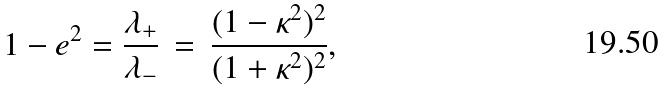Convert formula to latex. <formula><loc_0><loc_0><loc_500><loc_500>1 - e ^ { 2 } = \frac { { \lambda } _ { + } } { { \lambda } _ { - } } \, = \, \frac { ( 1 - { \kappa } ^ { 2 } ) ^ { 2 } } { ( 1 + { \kappa } ^ { 2 } ) ^ { 2 } } ,</formula> 